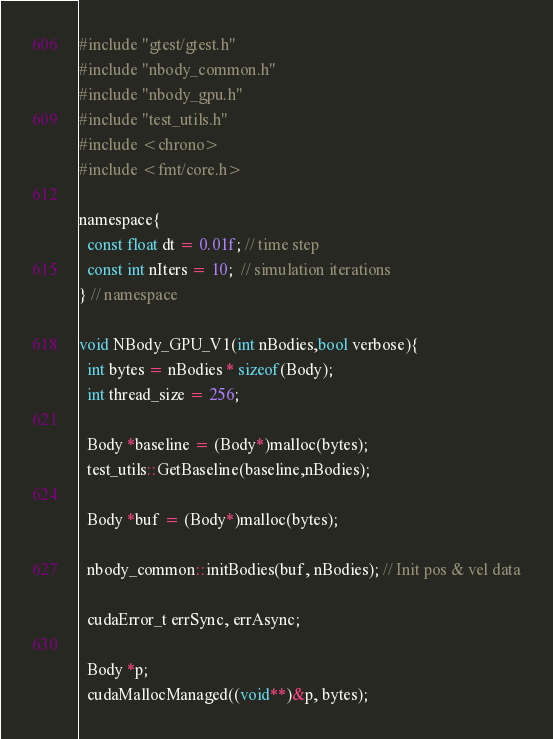Convert code to text. <code><loc_0><loc_0><loc_500><loc_500><_Cuda_>#include "gtest/gtest.h"
#include "nbody_common.h"
#include "nbody_gpu.h"
#include "test_utils.h"
#include <chrono>
#include <fmt/core.h>

namespace{
  const float dt = 0.01f; // time step
  const int nIters = 10;  // simulation iterations
} // namespace

void NBody_GPU_V1(int nBodies,bool verbose){
  int bytes = nBodies * sizeof(Body);
  int thread_size = 256;

  Body *baseline = (Body*)malloc(bytes);
  test_utils::GetBaseline(baseline,nBodies);  

  Body *buf = (Body*)malloc(bytes);

  nbody_common::initBodies(buf, nBodies); // Init pos & vel data

  cudaError_t errSync, errAsync;

  Body *p;
  cudaMallocManaged((void**)&p, bytes);</code> 